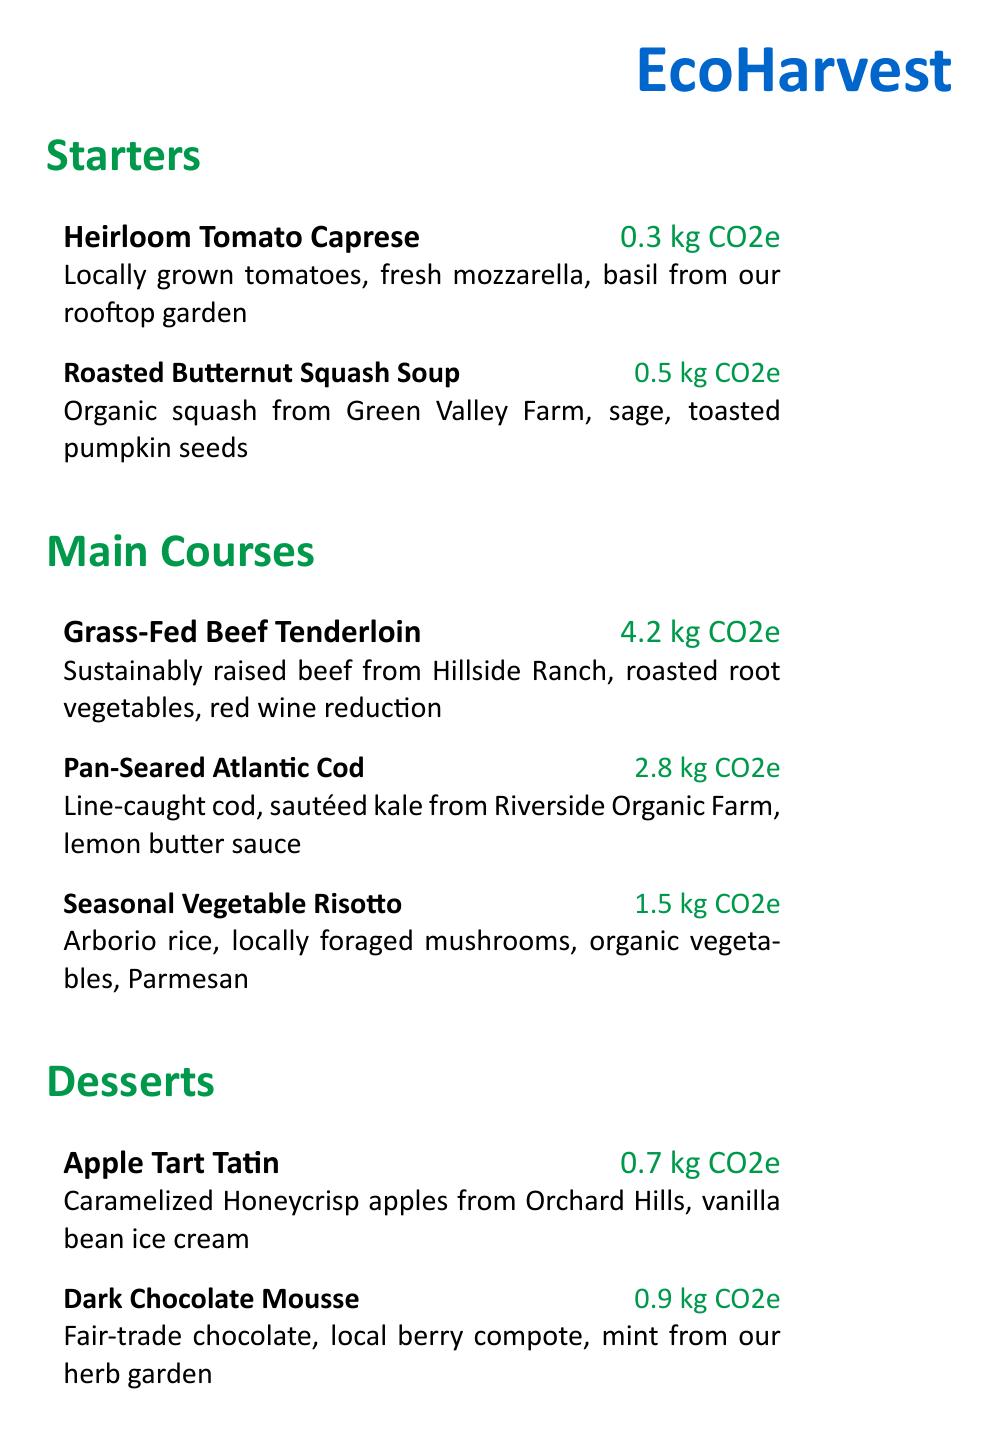what is the name of the restaurant? The name of the restaurant is prominently displayed at the top of the menu.
Answer: EcoHarvest how many carbon emissions does the Grass-Fed Beef Tenderloin produce? The carbon emissions for this dish are specified next to its description.
Answer: 4.2 kg CO2e which dessert includes local berry compote? The dessert menu lists the items along with their descriptions, identifying this specific ingredient.
Answer: Dark Chocolate Mousse what type of farm raises the beef for the Grass-Fed Beef Tenderloin? The menu provides details about sourcing for the dishes, indicating the type of farm for the beef.
Answer: Hillside Ranch how many kg CO2e does the Apple Tart Tatin produce? The carbon emissions for this dessert are indicated alongside its description on the menu.
Answer: 0.7 kg CO2e what initiative does EcoHarvest invest in for carbon offset? The document describes the restaurant's commitment to reducing emissions through specific actions mentioned at the bottom.
Answer: local reforestation projects what is the main ingredient in the Seasonal Vegetable Risotto? The main ingredients for each dish are listed in the description, highlighting the primary components.
Answer: Arborio rice how many starters are listed in the menu? The document lists dishes under each section, providing a count of starters.
Answer: 2 